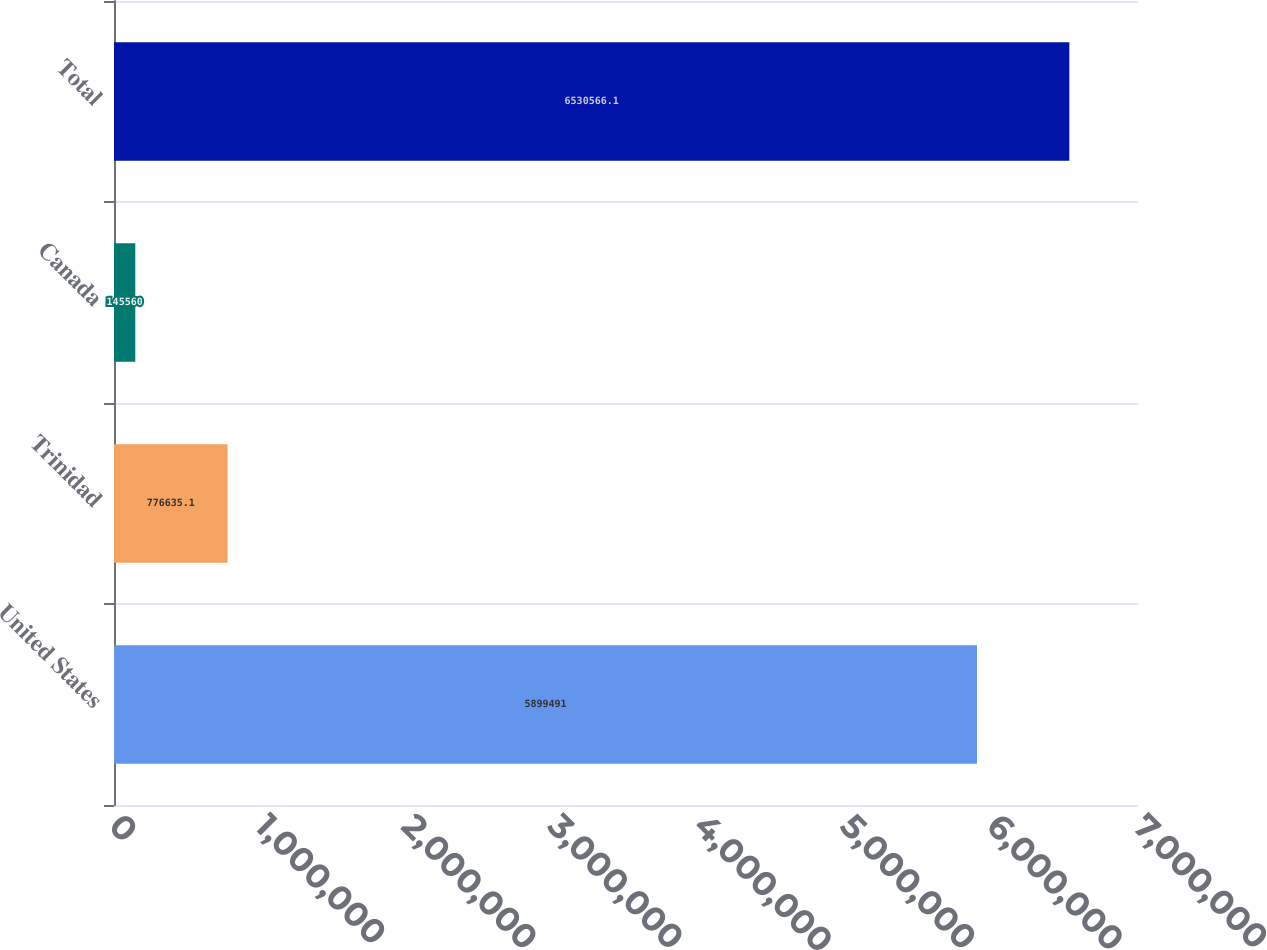<chart> <loc_0><loc_0><loc_500><loc_500><bar_chart><fcel>United States<fcel>Trinidad<fcel>Canada<fcel>Total<nl><fcel>5.89949e+06<fcel>776635<fcel>145560<fcel>6.53057e+06<nl></chart> 